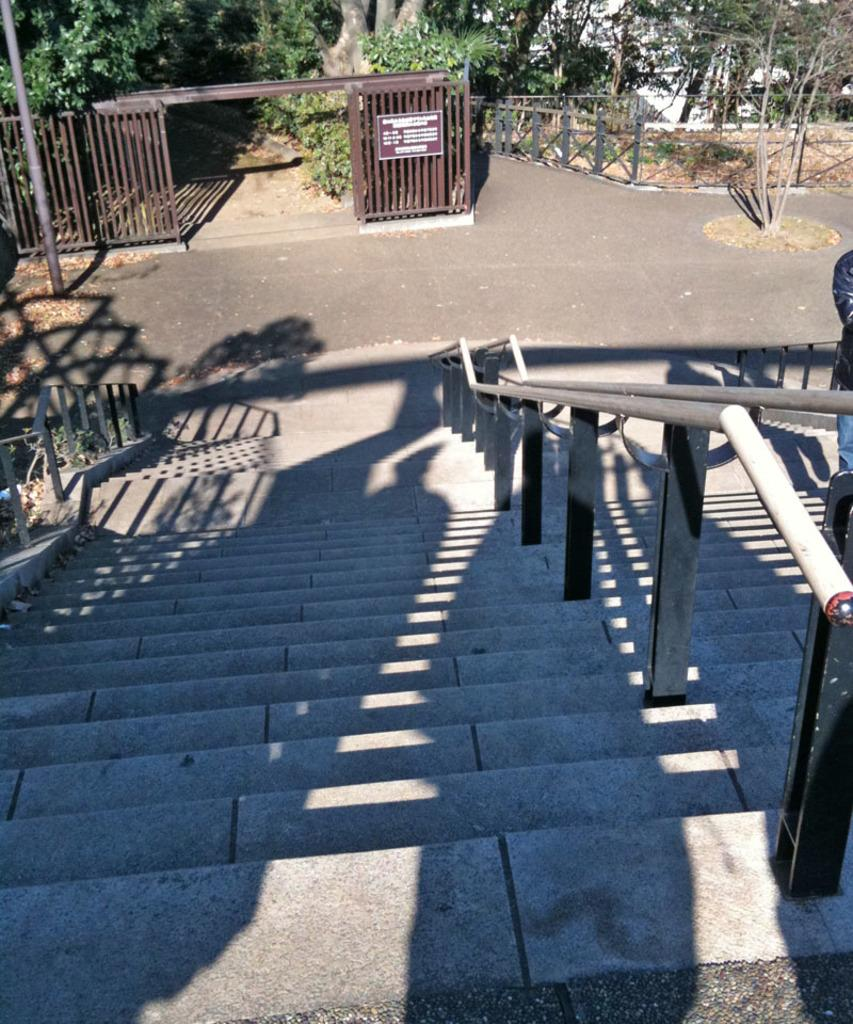What can be seen in the foreground of the image? There are steps and metal rods in the foreground of the image. What is visible in the background of the image? There is a fence, trees, a pole, and grass in the background of the image. Can you describe the lighting in the image? The image might have been taken during the day, as there is sufficient light to see the details. What type of plane can be seen in the image? There is no plane present in the image. What selection of items is being offered in the image? There is no selection of items being offered in the image; it features steps, metal rods, a fence, trees, a pole, and grass. 